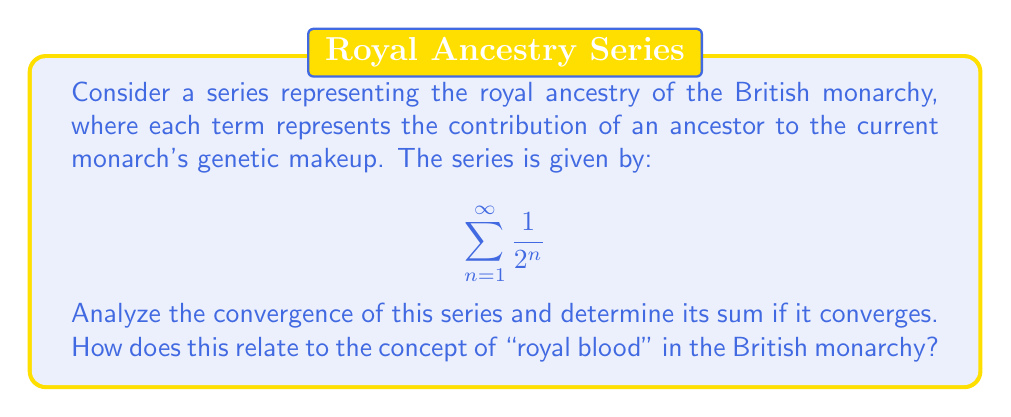Can you answer this question? To analyze the convergence of this series, we can use the concept of geometric series.

1) First, let's identify the components of our geometric series:
   - First term, $a = \frac{1}{2}$
   - Common ratio, $r = \frac{1}{2}$

2) For a geometric series $\sum_{n=1}^{\infty} ar^{n-1}$, it converges if $|r| < 1$.

3) In our case, $|r| = |\frac{1}{2}| = \frac{1}{2} < 1$, so the series converges.

4) For a convergent geometric series, the sum is given by the formula:

   $$S_{\infty} = \frac{a}{1-r} = \frac{\frac{1}{2}}{1-\frac{1}{2}} = \frac{\frac{1}{2}}{\frac{1}{2}} = 1$$

5) Therefore, the series converges to 1.

Relating this to the British monarchy:
- Each term $\frac{1}{2^n}$ represents the genetic contribution of an ancestor n generations back.
- The first term ($\frac{1}{2}$) represents parents, the second ($\frac{1}{4}$) grandparents, and so on.
- The sum being 1 implies that all of a person's genetic material comes from their ancestors (as expected).
- The concept of "royal blood" is somewhat misleading, as the contribution of very distant royal ancestors becomes negligibly small (represented by terms far along in the series).

This mathematical model provides a quantitative perspective on ancestry, showing how the genetic contribution of distant ancestors (including royalty) becomes increasingly small over generations.
Answer: The series $\sum_{n=1}^{\infty} \frac{1}{2^n}$ converges, and its sum is 1. 